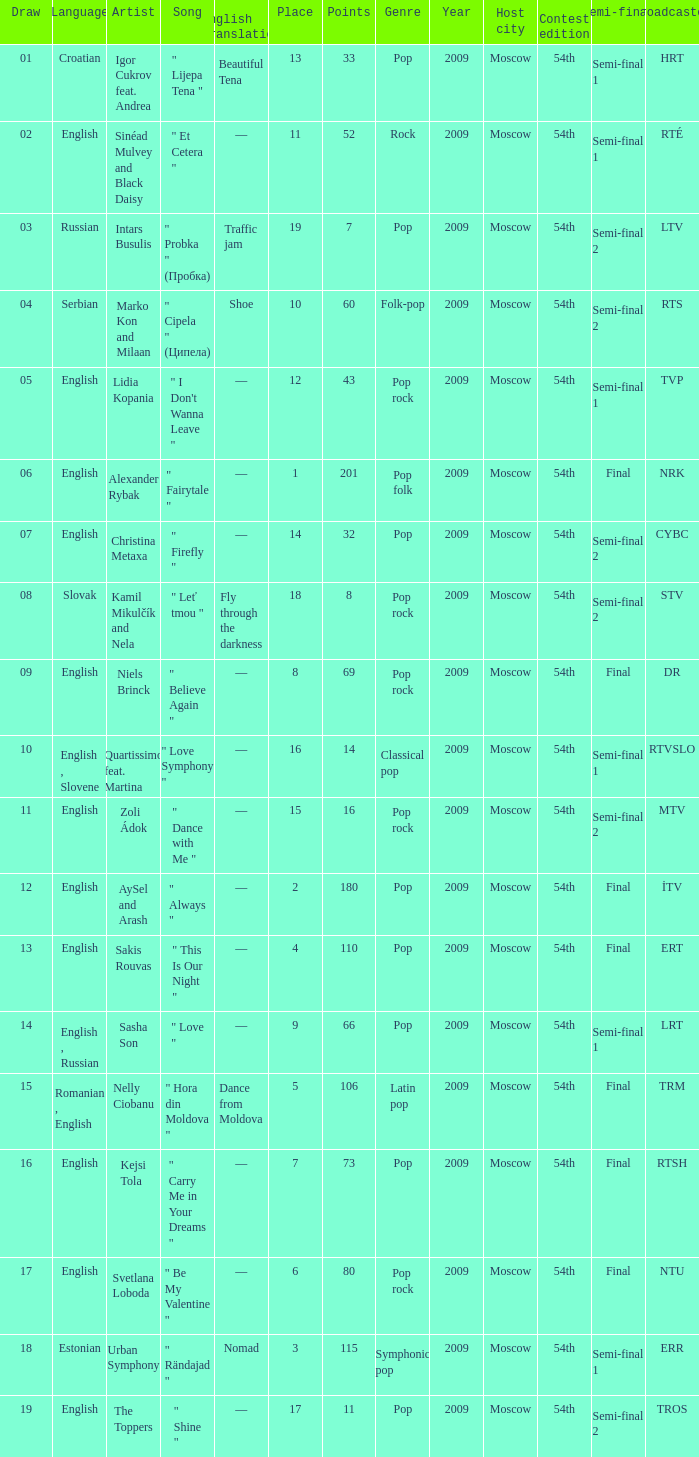What is the place when the draw is less than 12 and the artist is quartissimo feat. martina? 16.0. 